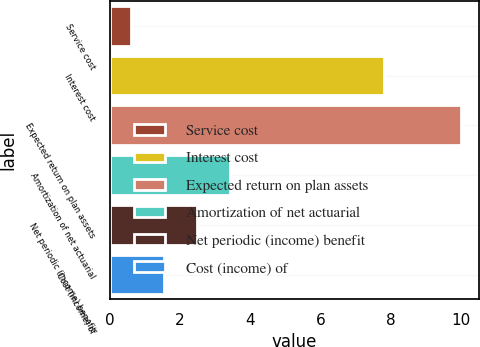<chart> <loc_0><loc_0><loc_500><loc_500><bar_chart><fcel>Service cost<fcel>Interest cost<fcel>Expected return on plan assets<fcel>Amortization of net actuarial<fcel>Net periodic (income) benefit<fcel>Cost (income) of<nl><fcel>0.6<fcel>7.8<fcel>10<fcel>3.42<fcel>2.48<fcel>1.54<nl></chart> 